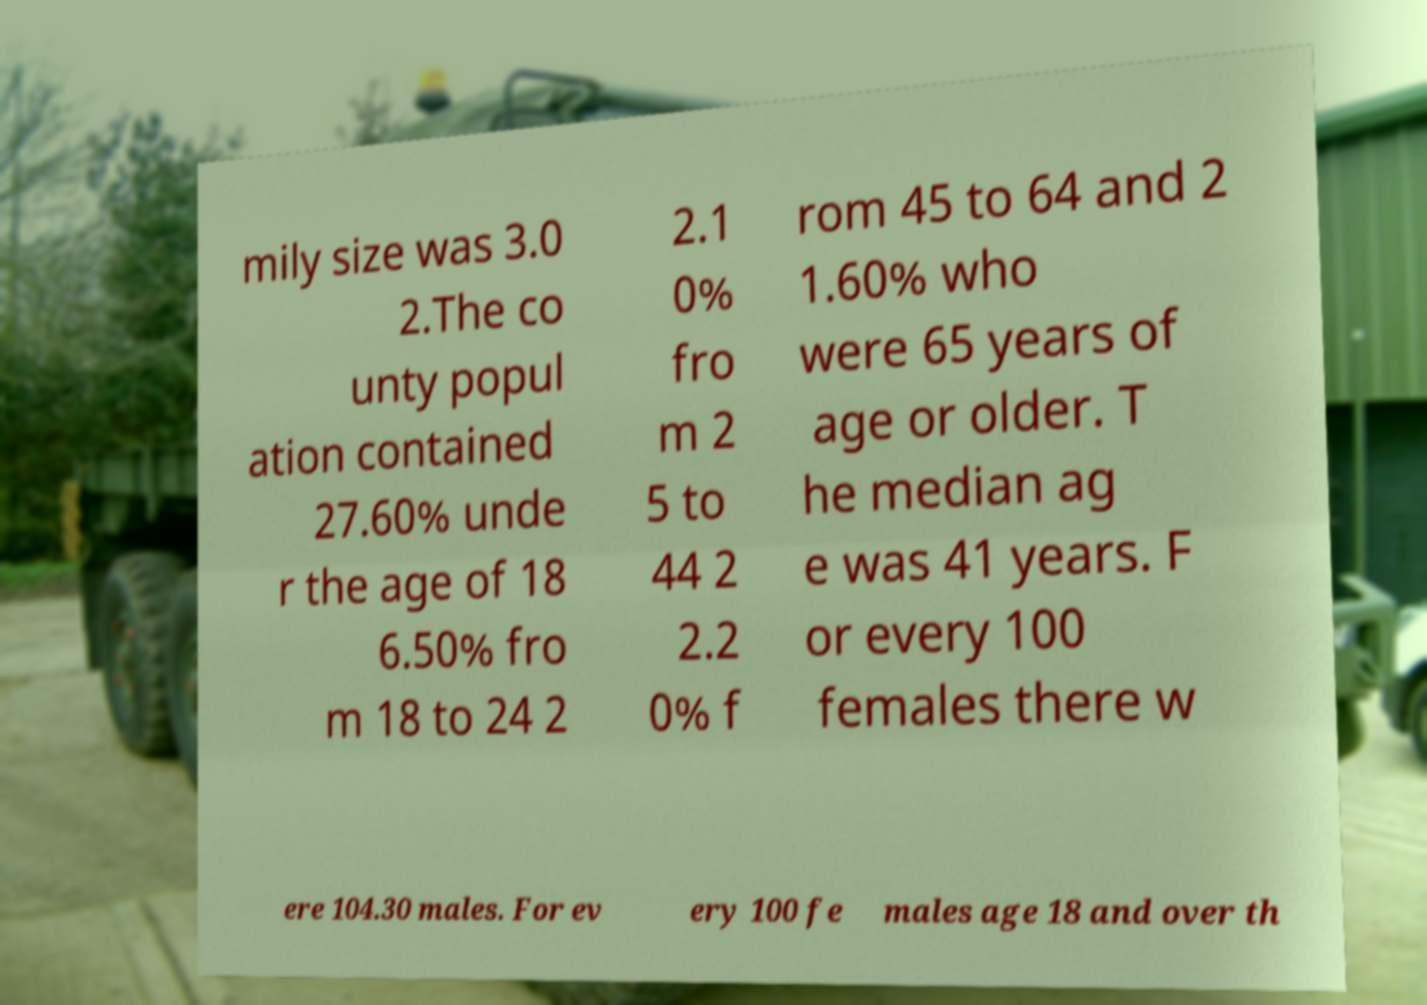Please read and relay the text visible in this image. What does it say? mily size was 3.0 2.The co unty popul ation contained 27.60% unde r the age of 18 6.50% fro m 18 to 24 2 2.1 0% fro m 2 5 to 44 2 2.2 0% f rom 45 to 64 and 2 1.60% who were 65 years of age or older. T he median ag e was 41 years. F or every 100 females there w ere 104.30 males. For ev ery 100 fe males age 18 and over th 